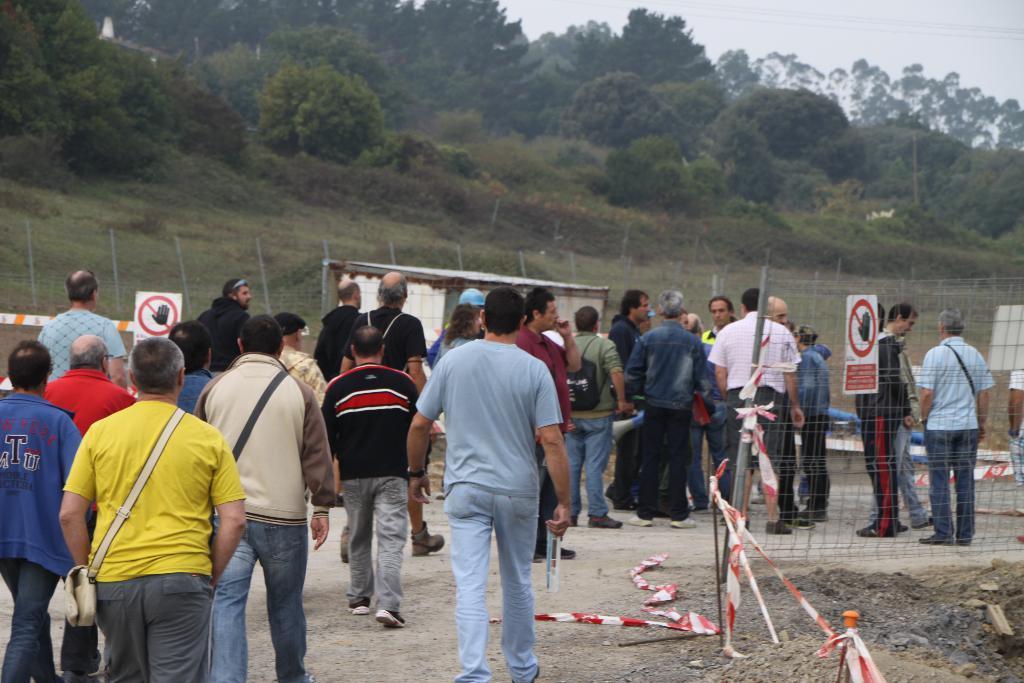Describe this image in one or two sentences. In this picture there are people in the center of the image and there is boundary in front of them and there are trees at the top side of the image. 